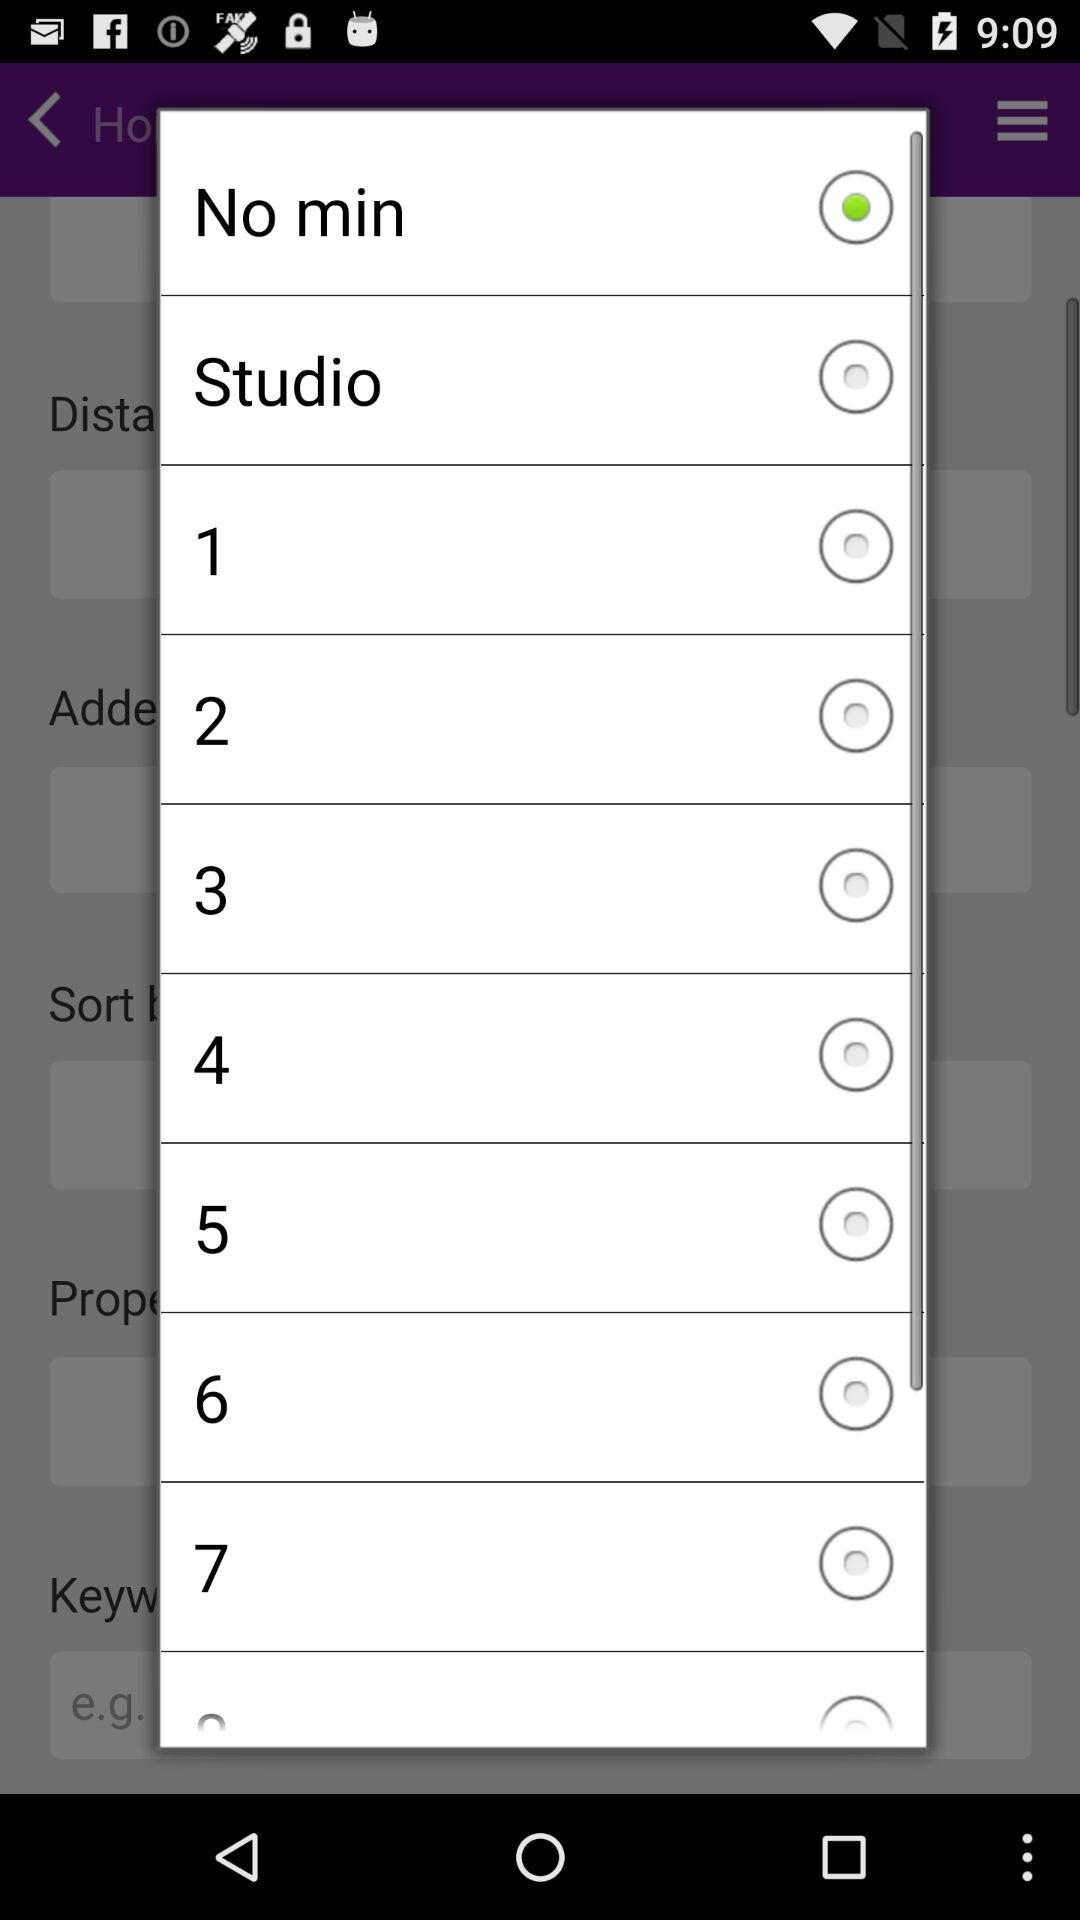Which option was selected? The selected option was "No min". 